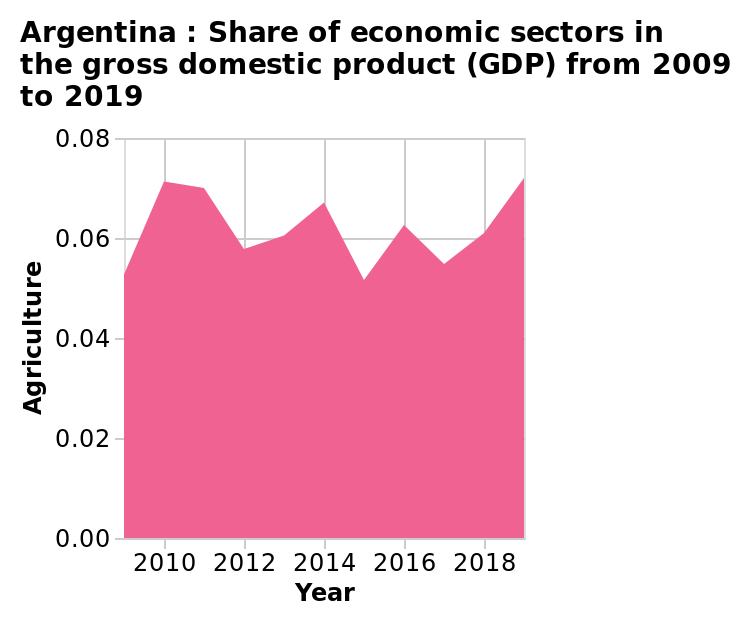<image>
Does the share of Agriculture remain constant over the years?  No, the share of Agriculture fluctuates over the years. What is the name of the diagram mentioned in the figure?  The diagram mentioned in the figure is named Argentina: Share of economic sectors in the gross domestic product (GDP) from 2009 to 2019. please enumerates aspects of the construction of the chart Here a area diagram is named Argentina : Share of economic sectors in the gross domestic product (GDP) from 2009 to 2019. The x-axis plots Year while the y-axis shows Agriculture. Can the share of Agriculture go below 0.05?  The description does not provide information about whether the share of Agriculture can go below 0.05. What is the highest recorded share of Agriculture?  The description does not provide information about the highest recorded share of Agriculture. Is the share of Agriculture always below 0.05?  No, the share of Agriculture generally stays above 0.05. What is the time period covered by the diagram?  The diagram covers the years from 2009 to 2019. Offer a thorough analysis of the image. The lowest share of GDP for agriculture occurred in 2015. The highest share occurred in 2019. Agriculture shared more than 0.5 each year between 2009 and 2019. Did the lowest share of GDP for agriculture occur in 2015 and the highest share occur in 2019, with agriculture sharing less than 0.5 each year between 2009 and 2019? No.The lowest share of GDP for agriculture occurred in 2015. The highest share occurred in 2019. Agriculture shared more than 0.5 each year between 2009 and 2019. 